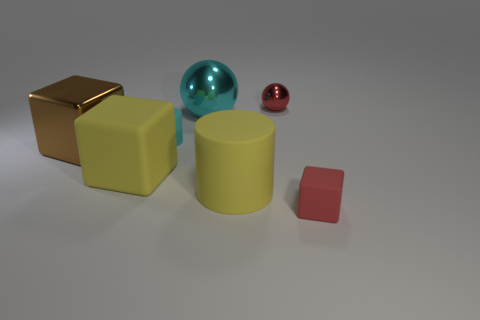Add 2 brown blocks. How many objects exist? 9 Subtract all cylinders. How many objects are left? 5 Add 2 large balls. How many large balls exist? 3 Subtract 0 gray blocks. How many objects are left? 7 Subtract all tiny cyan matte things. Subtract all tiny matte objects. How many objects are left? 4 Add 5 tiny cyan rubber things. How many tiny cyan rubber things are left? 6 